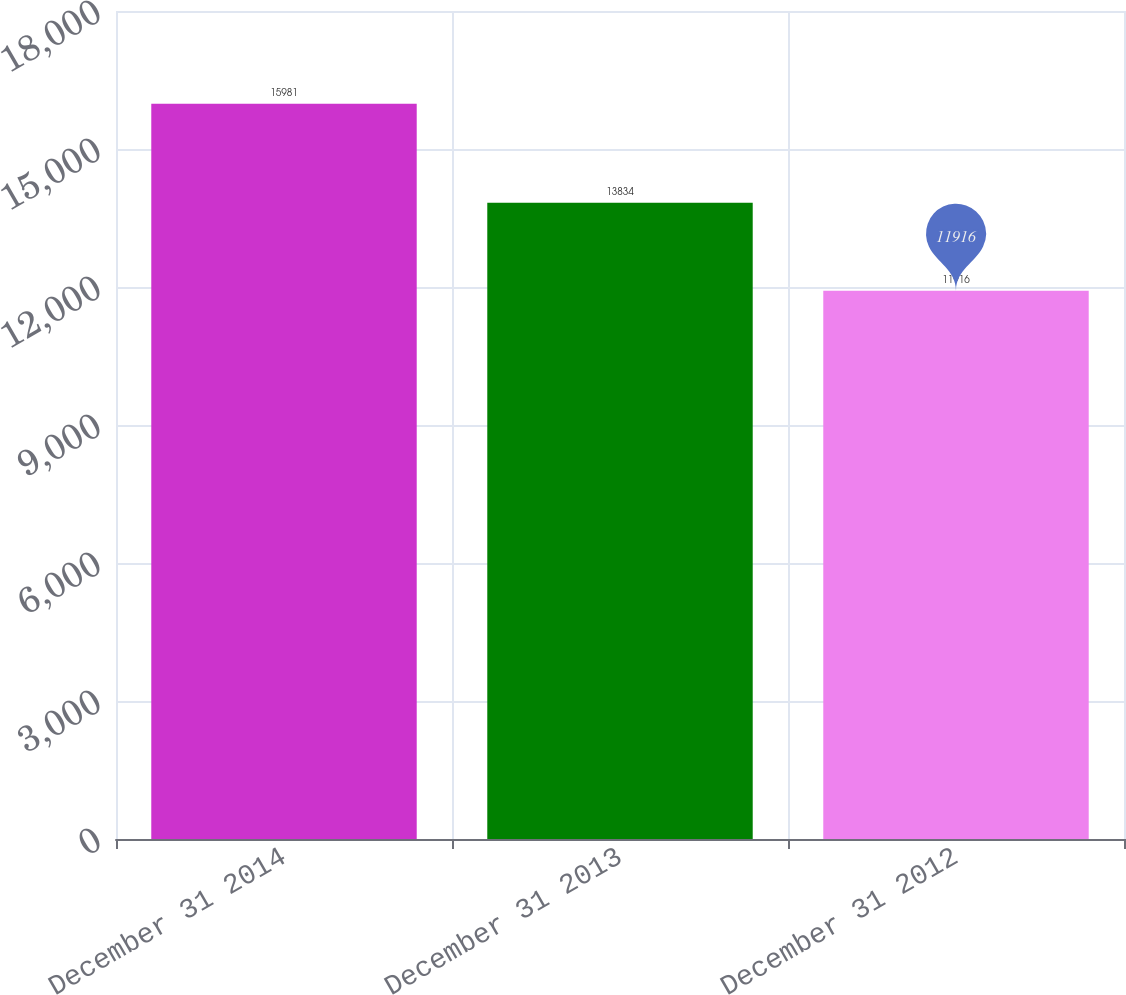Convert chart. <chart><loc_0><loc_0><loc_500><loc_500><bar_chart><fcel>December 31 2014<fcel>December 31 2013<fcel>December 31 2012<nl><fcel>15981<fcel>13834<fcel>11916<nl></chart> 